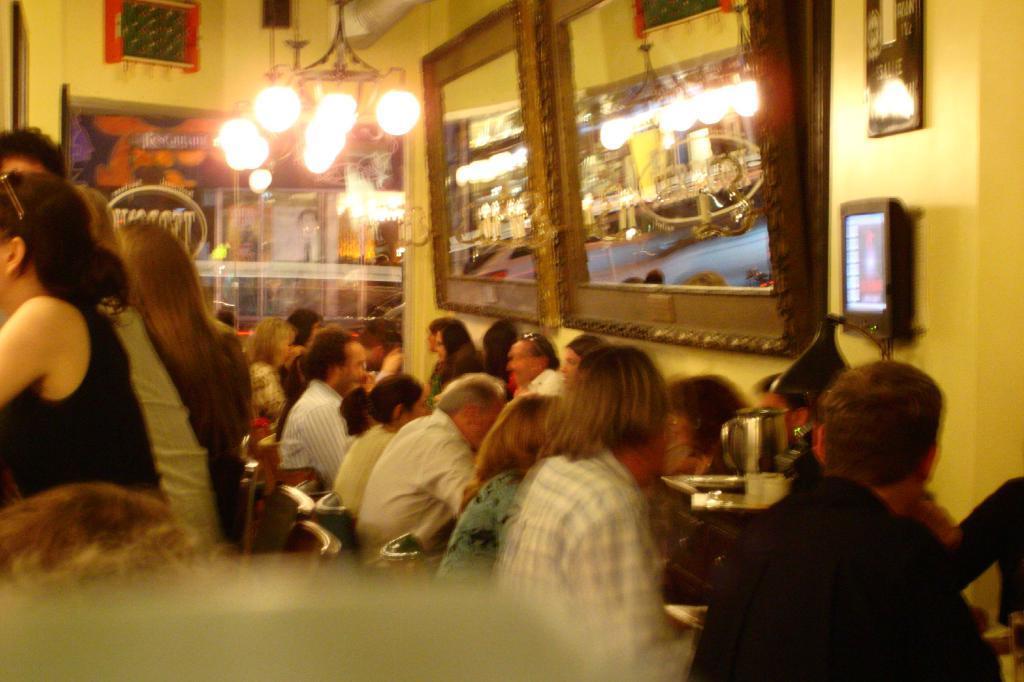In one or two sentences, can you explain what this image depicts? In this picture we can observe some people sitting in the chairs in front of their respective tables. There are men and women in this picture. On the right side we can observe two mirrors fixed to the wall. We can observe a chandelier here. In the background there is a wall. 